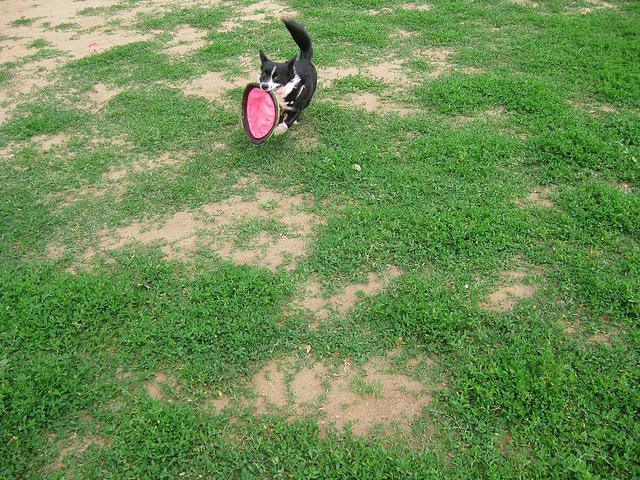How many surfboards are there?
Give a very brief answer. 0. 